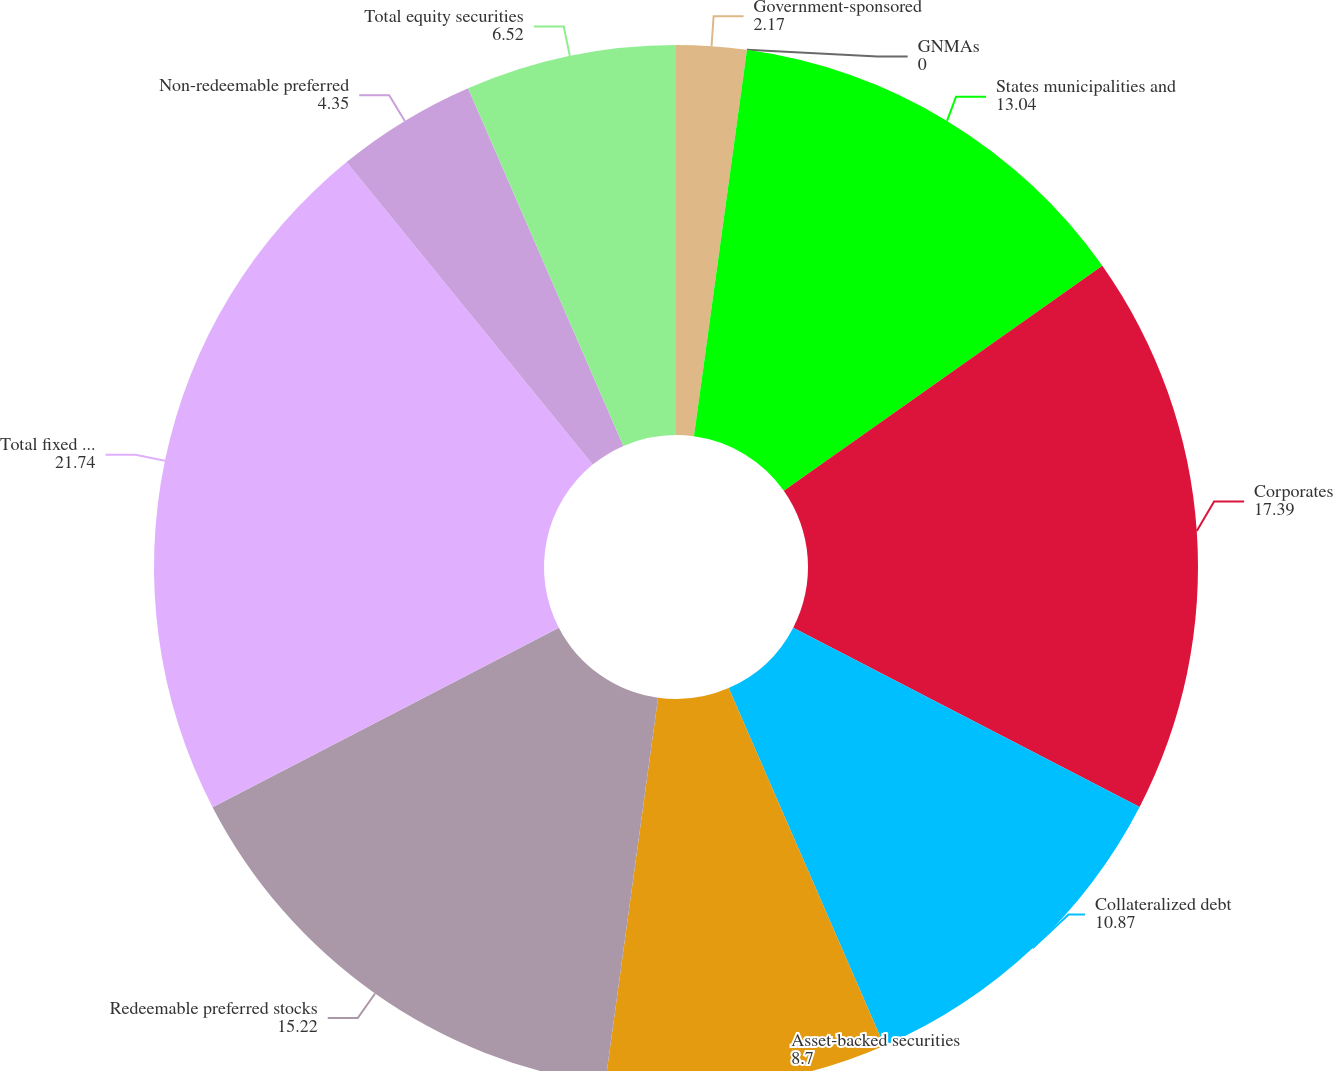Convert chart. <chart><loc_0><loc_0><loc_500><loc_500><pie_chart><fcel>Government-sponsored<fcel>GNMAs<fcel>States municipalities and<fcel>Corporates<fcel>Collateralized debt<fcel>Asset-backed securities<fcel>Redeemable preferred stocks<fcel>Total fixed maturities<fcel>Non-redeemable preferred<fcel>Total equity securities<nl><fcel>2.17%<fcel>0.0%<fcel>13.04%<fcel>17.39%<fcel>10.87%<fcel>8.7%<fcel>15.22%<fcel>21.74%<fcel>4.35%<fcel>6.52%<nl></chart> 